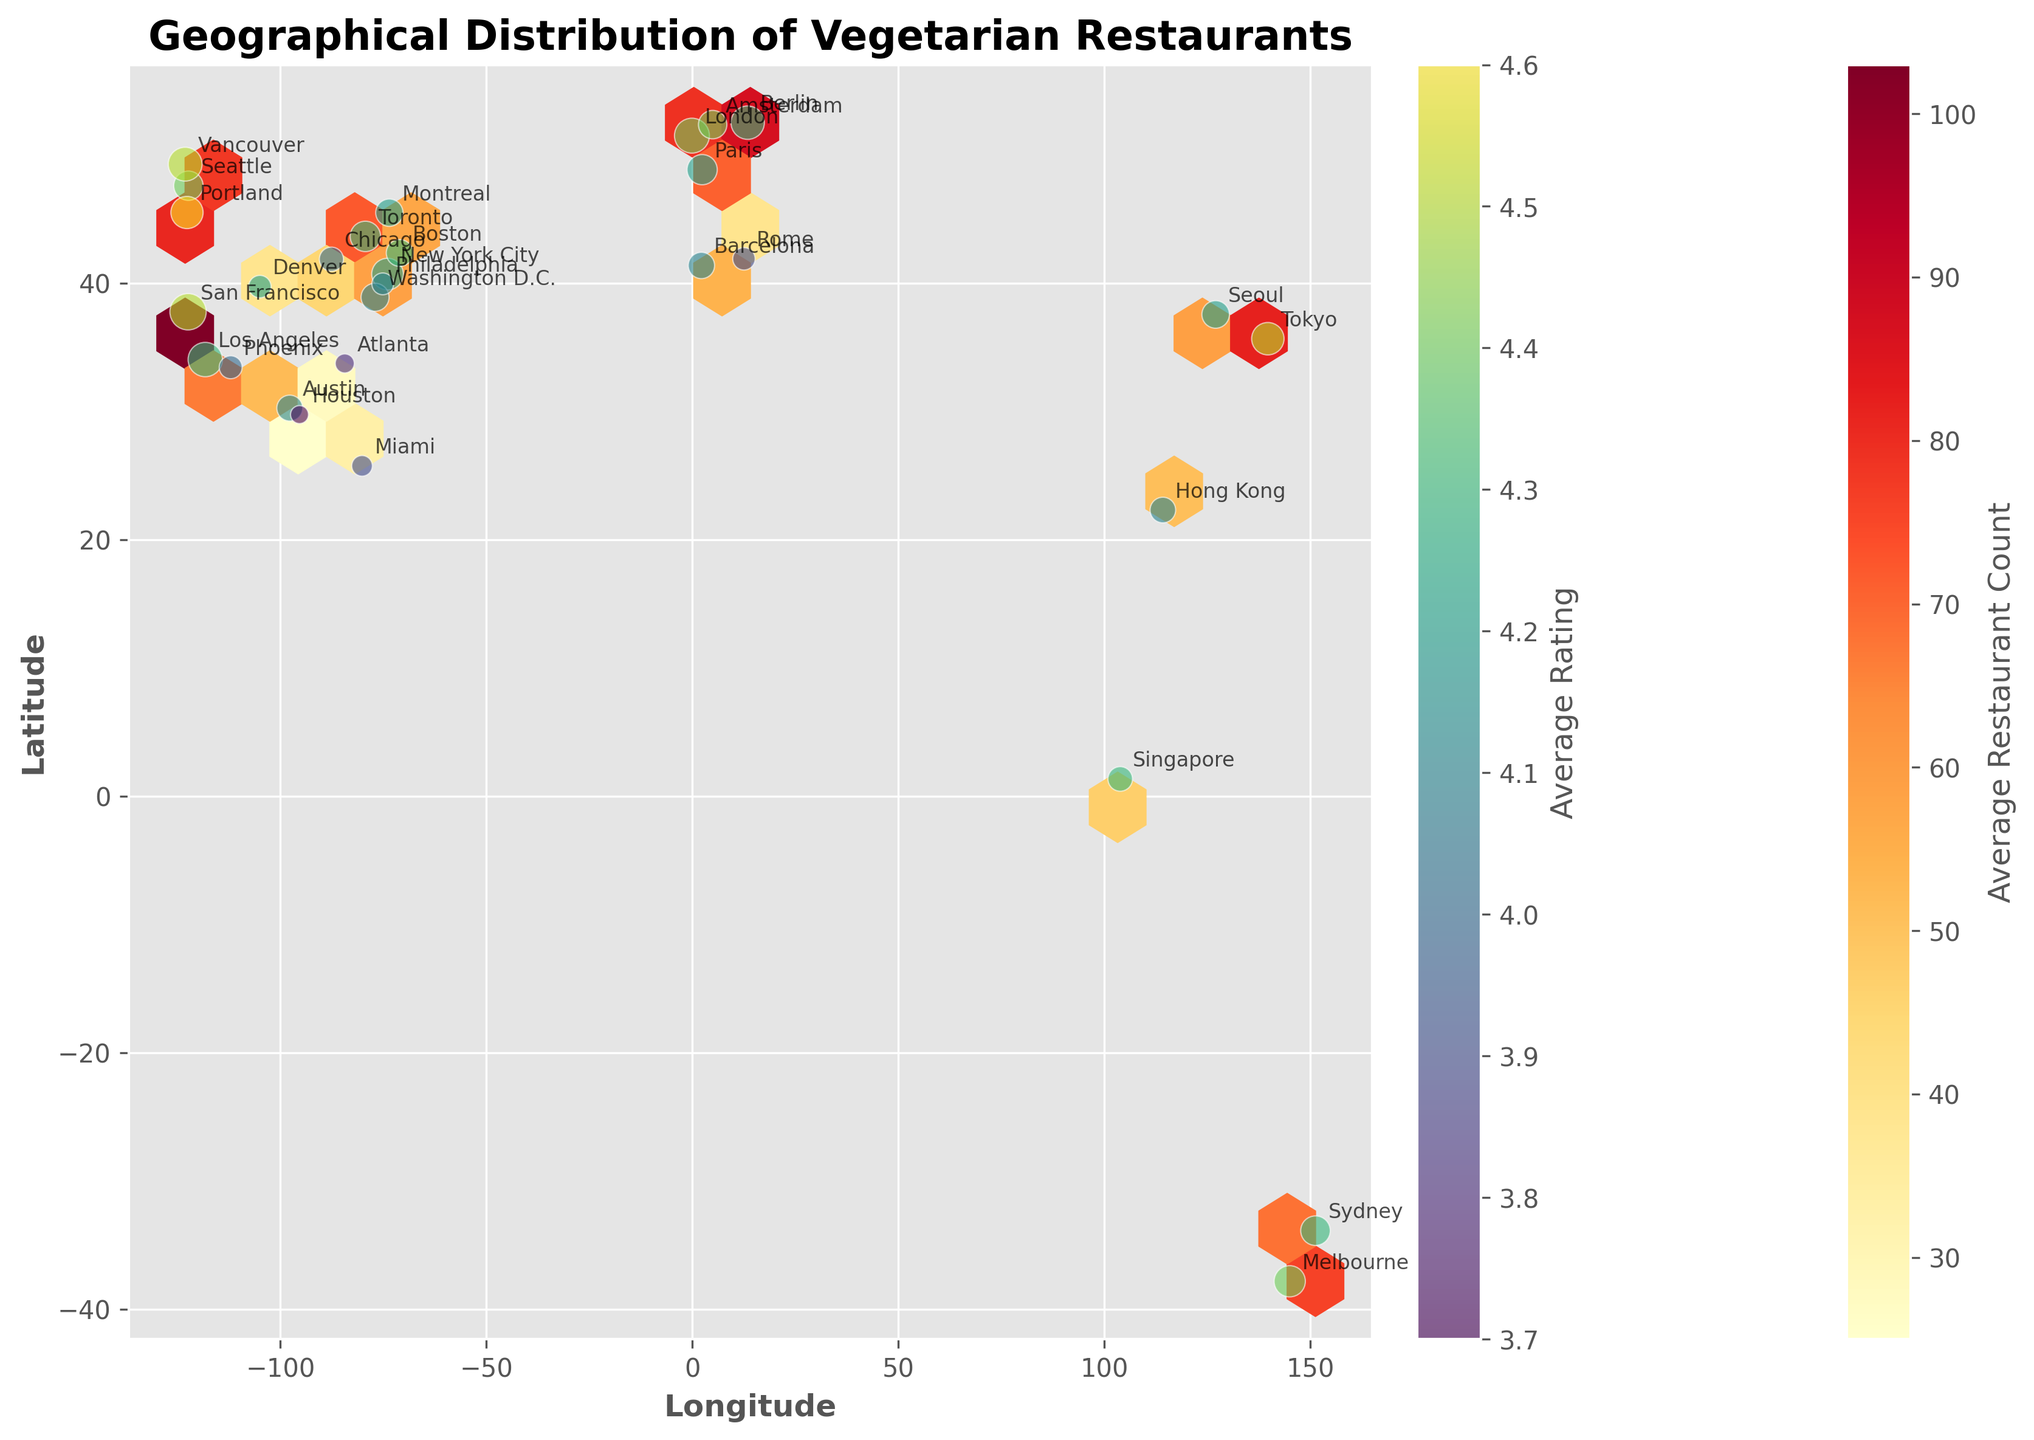What is the title of the plot? The title of the plot is shown at the top of the figure.
Answer: Geographical Distribution of Vegetarian Restaurants How is the average restaurant count represented in the plot? The color of the hexagons represents the average restaurant count, as indicated by the color bar labeled 'Average Restaurant Count'.
Answer: By the color of the hexagons What does the scatter point size indicate? The size of the scatter points is proportional to the RestaurantCount for each city.
Answer: RestaurantCount Which city has the highest average rating for vegetarian restaurants? The average rating is represented by the color of the scatter points, and Tokyo stands out with a color indicating the highest rating.
Answer: Tokyo Which city has a higher average rating, Seattle or New York City? By comparing the color of the scatter points for Seattle and New York City, it is clear that Seattle has a deeper color indicating a higher average rating.
Answer: Seattle Which city is located furthest to the west on the plot? By checking the scatter points' positions along the longitude axis, which increases from left to right, the furthest west city is Tokyo.
Answer: Tokyo How many cities are located between the latitudes 30 and 40? By counting the scatter points that fall within the latitude range of 30 to 40 on the y-axis.
Answer: 8 Which has a higher average restaurant count, London or Berlin? By comparing the color intensity of the hexagons where London and Berlin are located, London has a higher color intensity indicating a higher average restaurant count.
Answer: London What's the color of the hexagon representing the average restaurant count around New York City? The hexagon color around New York City can be derived from the color bar. It falls within a yellow-orange hue.
Answer: Yellow-orange Do cities with larger restaurant counts generally have higher average ratings? It is observed that larger scatter points (higher restaurant counts) often exhibit brighter colors (higher ratings) like Portland and Tokyo, indicating a positive correlation.
Answer: Yes 